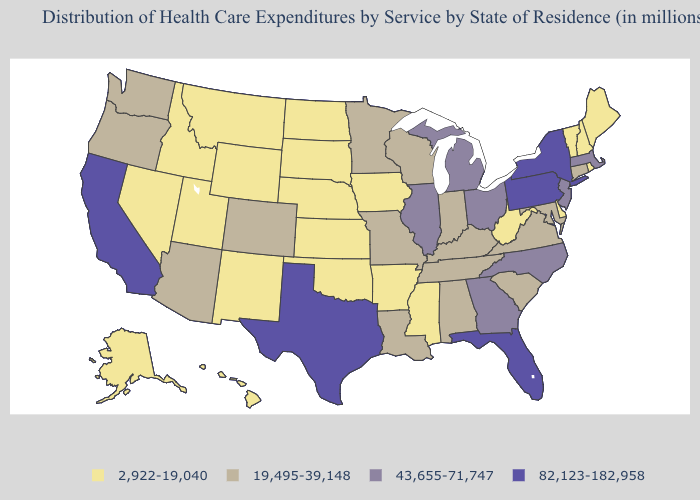Among the states that border Georgia , does Tennessee have the highest value?
Give a very brief answer. No. Name the states that have a value in the range 43,655-71,747?
Answer briefly. Georgia, Illinois, Massachusetts, Michigan, New Jersey, North Carolina, Ohio. What is the value of Arkansas?
Keep it brief. 2,922-19,040. Which states hav the highest value in the South?
Quick response, please. Florida, Texas. Does New York have the highest value in the USA?
Concise answer only. Yes. What is the lowest value in the MidWest?
Concise answer only. 2,922-19,040. What is the value of Kentucky?
Give a very brief answer. 19,495-39,148. Which states have the lowest value in the USA?
Short answer required. Alaska, Arkansas, Delaware, Hawaii, Idaho, Iowa, Kansas, Maine, Mississippi, Montana, Nebraska, Nevada, New Hampshire, New Mexico, North Dakota, Oklahoma, Rhode Island, South Dakota, Utah, Vermont, West Virginia, Wyoming. What is the value of Hawaii?
Give a very brief answer. 2,922-19,040. Does Maryland have the lowest value in the USA?
Answer briefly. No. Which states have the lowest value in the USA?
Give a very brief answer. Alaska, Arkansas, Delaware, Hawaii, Idaho, Iowa, Kansas, Maine, Mississippi, Montana, Nebraska, Nevada, New Hampshire, New Mexico, North Dakota, Oklahoma, Rhode Island, South Dakota, Utah, Vermont, West Virginia, Wyoming. How many symbols are there in the legend?
Write a very short answer. 4. Name the states that have a value in the range 82,123-182,958?
Write a very short answer. California, Florida, New York, Pennsylvania, Texas. Does Oklahoma have the lowest value in the USA?
Answer briefly. Yes. Among the states that border Iowa , does Nebraska have the lowest value?
Be succinct. Yes. 